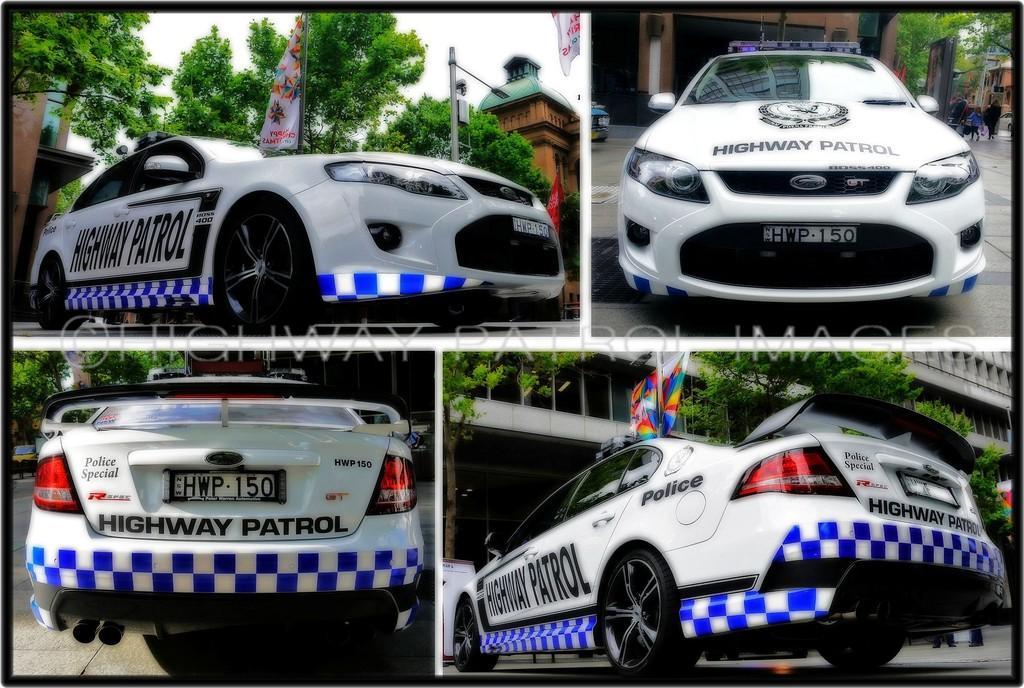Describe this image in one or two sentences. In this image we can see a collage image of a police car on the road, with some texts written on it, we can also see some people, trees, flags, street light pole, a building. 